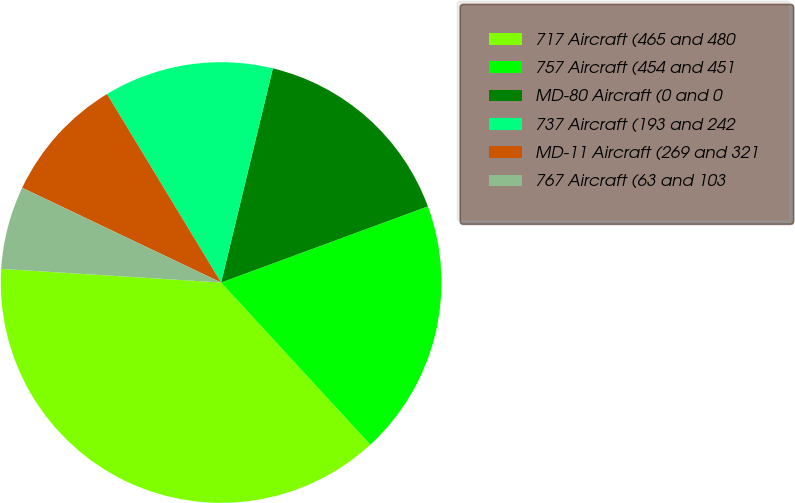<chart> <loc_0><loc_0><loc_500><loc_500><pie_chart><fcel>717 Aircraft (465 and 480<fcel>757 Aircraft (454 and 451<fcel>MD-80 Aircraft (0 and 0<fcel>737 Aircraft (193 and 242<fcel>MD-11 Aircraft (269 and 321<fcel>767 Aircraft (63 and 103<nl><fcel>37.82%<fcel>18.78%<fcel>15.61%<fcel>12.44%<fcel>9.26%<fcel>6.09%<nl></chart> 